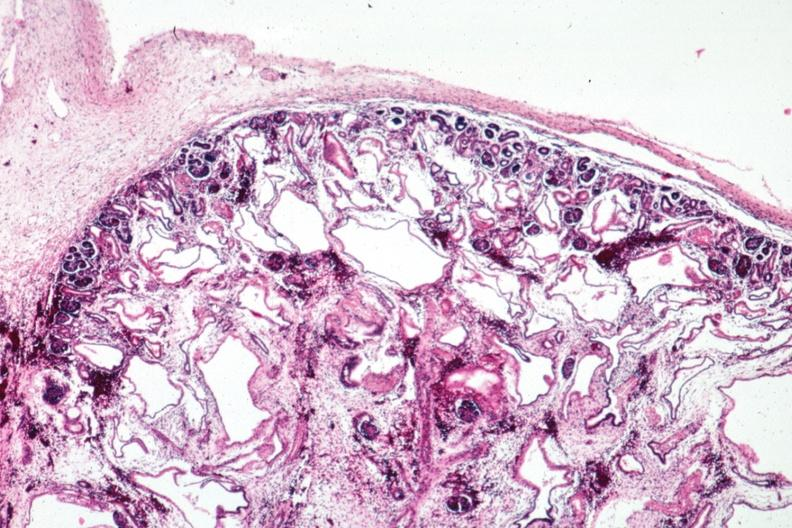what is present?
Answer the question using a single word or phrase. Kidney 